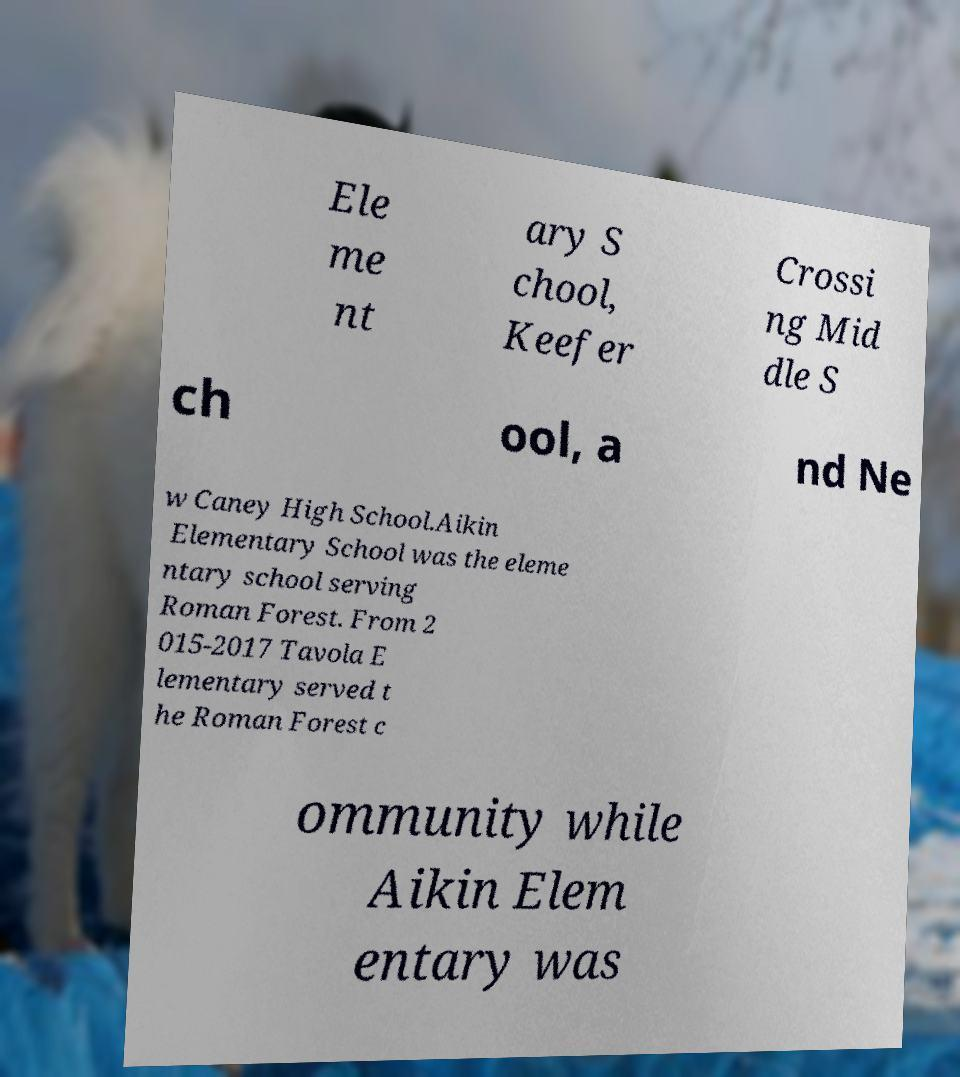Could you extract and type out the text from this image? Ele me nt ary S chool, Keefer Crossi ng Mid dle S ch ool, a nd Ne w Caney High School.Aikin Elementary School was the eleme ntary school serving Roman Forest. From 2 015-2017 Tavola E lementary served t he Roman Forest c ommunity while Aikin Elem entary was 